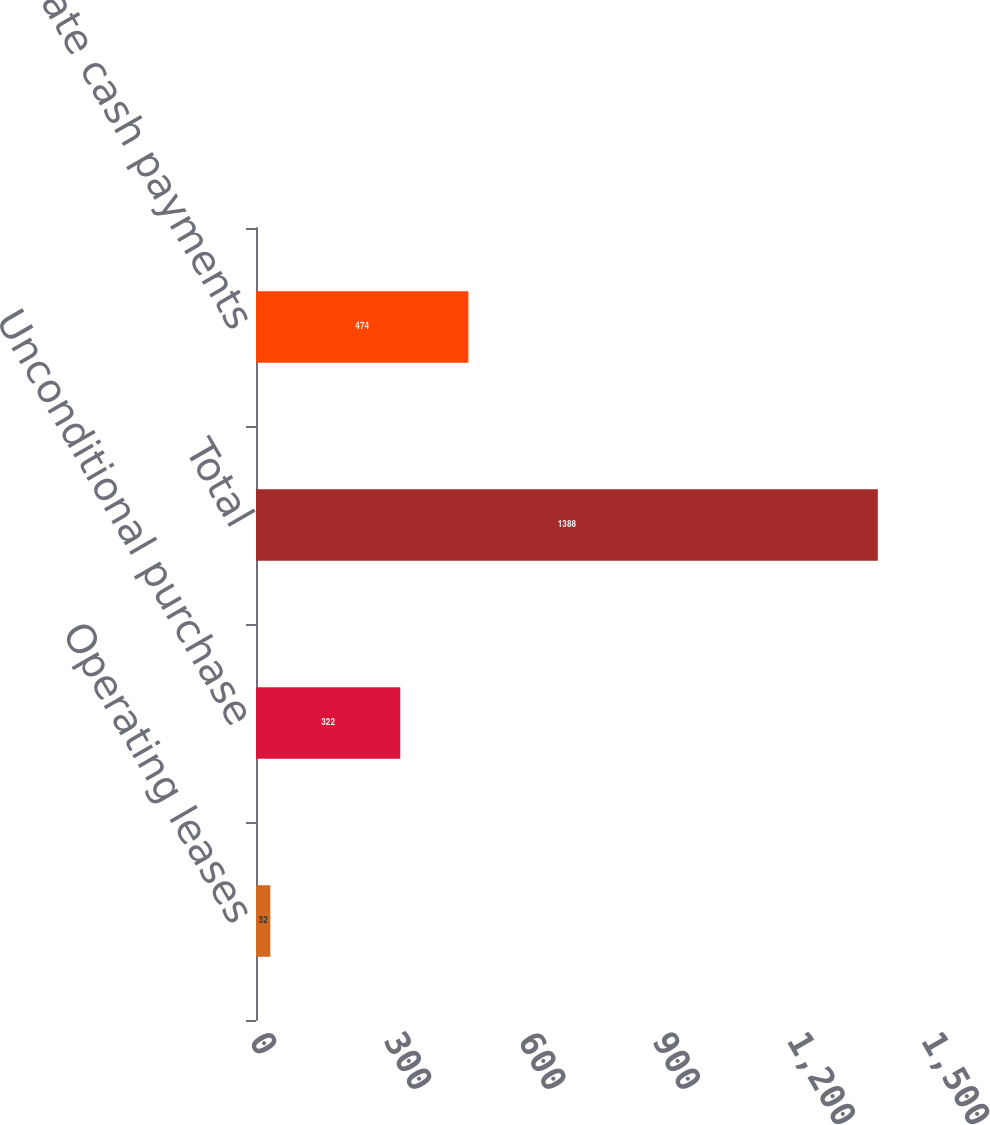Convert chart to OTSL. <chart><loc_0><loc_0><loc_500><loc_500><bar_chart><fcel>Operating leases<fcel>Unconditional purchase<fcel>Total<fcel>Aggregate cash payments<nl><fcel>32<fcel>322<fcel>1388<fcel>474<nl></chart> 